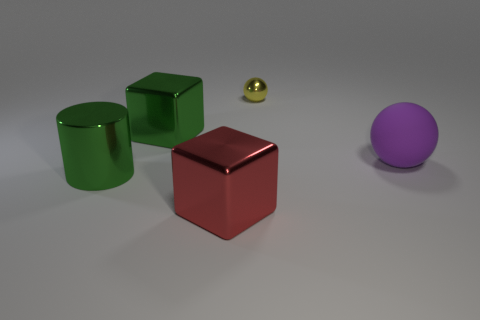There is a green object that is in front of the purple thing; is it the same size as the red block?
Your answer should be compact. Yes. Are there any metallic blocks that are on the right side of the green object right of the green metal cylinder?
Offer a very short reply. Yes. What material is the large green cube?
Give a very brief answer. Metal. There is a large purple matte sphere; are there any metal cylinders in front of it?
Offer a terse response. Yes. What is the size of the purple thing that is the same shape as the small yellow thing?
Your answer should be very brief. Large. Are there an equal number of red shiny cubes behind the big red cube and small objects in front of the green cylinder?
Make the answer very short. Yes. How many big metallic blocks are there?
Provide a succinct answer. 2. Is the number of big shiny cylinders that are in front of the green shiny cube greater than the number of tiny brown rubber spheres?
Your answer should be compact. Yes. There is a block that is to the left of the red object; what material is it?
Ensure brevity in your answer.  Metal. There is a metallic object that is the same shape as the large matte thing; what is its color?
Your answer should be compact. Yellow. 